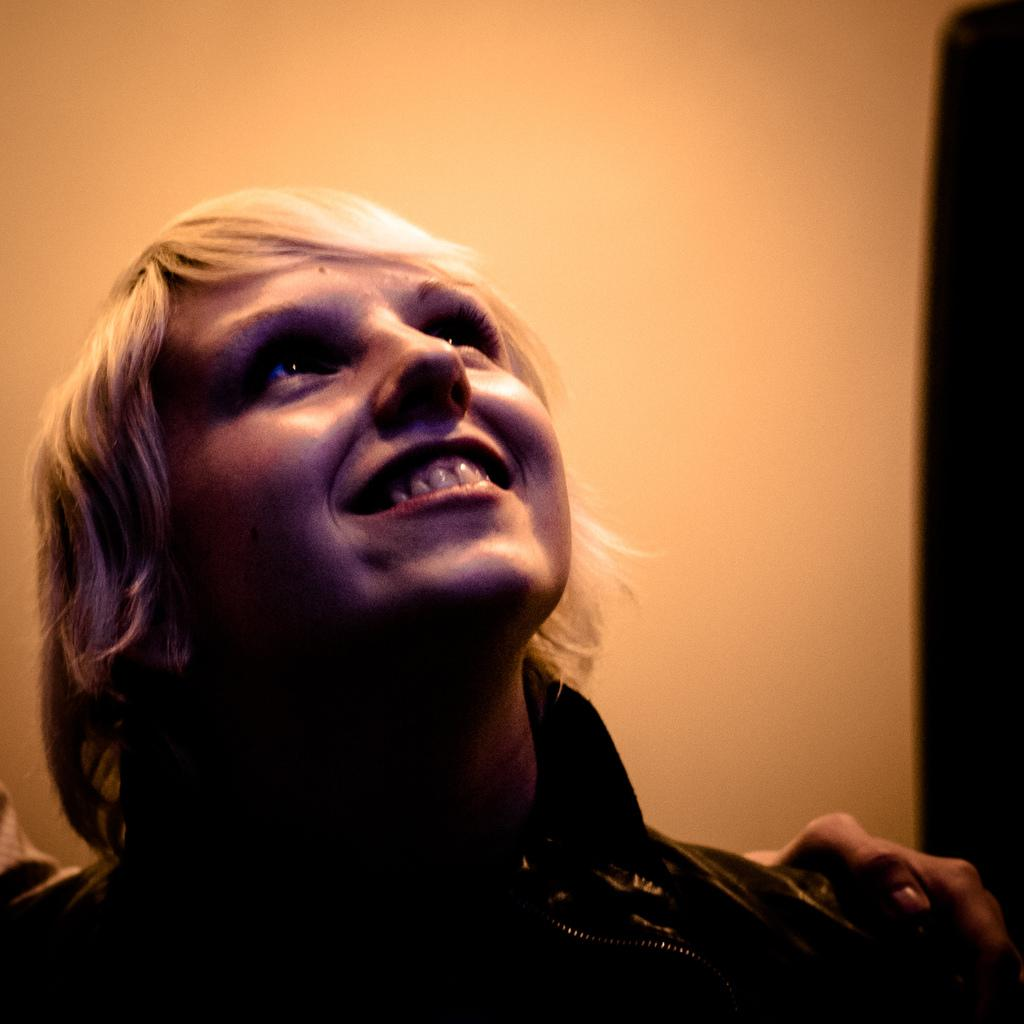What is present in the image? There is a person in the image. How is the person's expression in the image? The person is smiling. What can be seen in the background of the image? There is a wall in the background of the image. What type of rings can be seen on the person's fingers in the image? There are no rings visible on the person's fingers in the image. What emotion might the person be feeling, other than happiness, based on their smile? It is not possible to determine any other emotions the person might be feeling based solely on their smile in the image. 